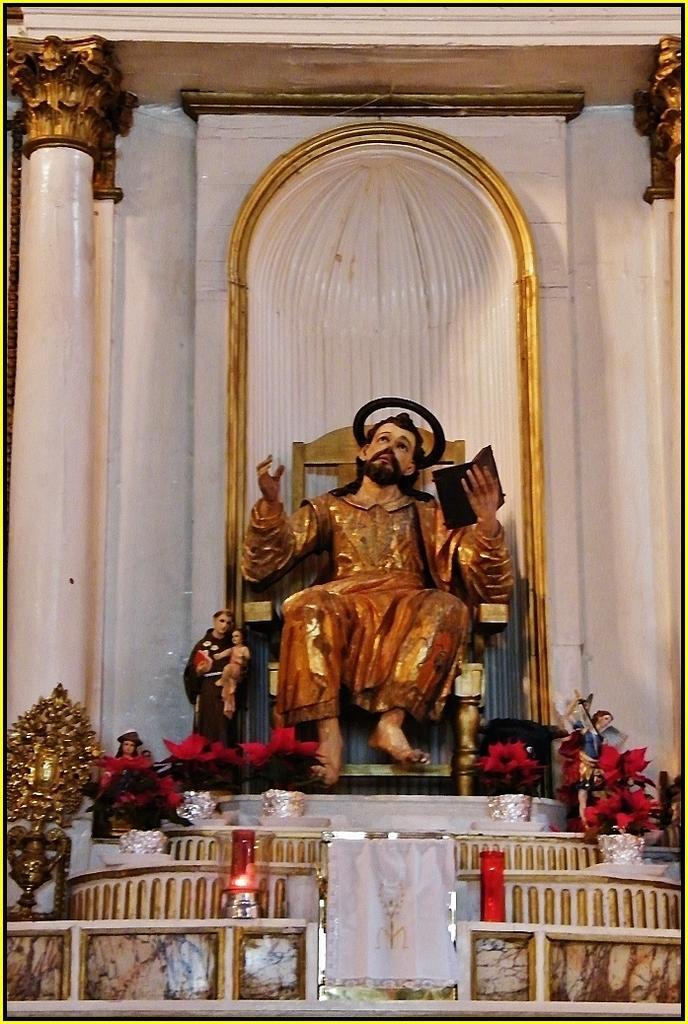How would you summarize this image in a sentence or two? In this picture we can see sculptures, flower pots, small white curtain, pillars and a candle chimney. 